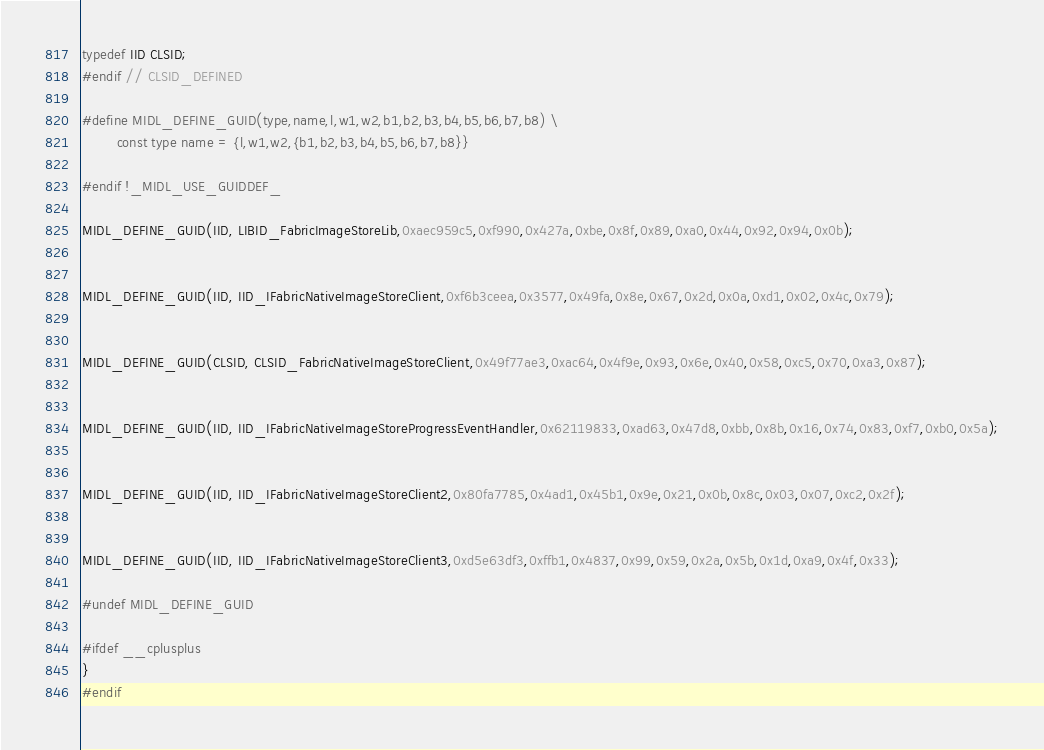<code> <loc_0><loc_0><loc_500><loc_500><_C_>typedef IID CLSID;
#endif // CLSID_DEFINED

#define MIDL_DEFINE_GUID(type,name,l,w1,w2,b1,b2,b3,b4,b5,b6,b7,b8) \
        const type name = {l,w1,w2,{b1,b2,b3,b4,b5,b6,b7,b8}}

#endif !_MIDL_USE_GUIDDEF_

MIDL_DEFINE_GUID(IID, LIBID_FabricImageStoreLib,0xaec959c5,0xf990,0x427a,0xbe,0x8f,0x89,0xa0,0x44,0x92,0x94,0x0b);


MIDL_DEFINE_GUID(IID, IID_IFabricNativeImageStoreClient,0xf6b3ceea,0x3577,0x49fa,0x8e,0x67,0x2d,0x0a,0xd1,0x02,0x4c,0x79);


MIDL_DEFINE_GUID(CLSID, CLSID_FabricNativeImageStoreClient,0x49f77ae3,0xac64,0x4f9e,0x93,0x6e,0x40,0x58,0xc5,0x70,0xa3,0x87);


MIDL_DEFINE_GUID(IID, IID_IFabricNativeImageStoreProgressEventHandler,0x62119833,0xad63,0x47d8,0xbb,0x8b,0x16,0x74,0x83,0xf7,0xb0,0x5a);


MIDL_DEFINE_GUID(IID, IID_IFabricNativeImageStoreClient2,0x80fa7785,0x4ad1,0x45b1,0x9e,0x21,0x0b,0x8c,0x03,0x07,0xc2,0x2f);


MIDL_DEFINE_GUID(IID, IID_IFabricNativeImageStoreClient3,0xd5e63df3,0xffb1,0x4837,0x99,0x59,0x2a,0x5b,0x1d,0xa9,0x4f,0x33);

#undef MIDL_DEFINE_GUID

#ifdef __cplusplus
}
#endif



</code> 